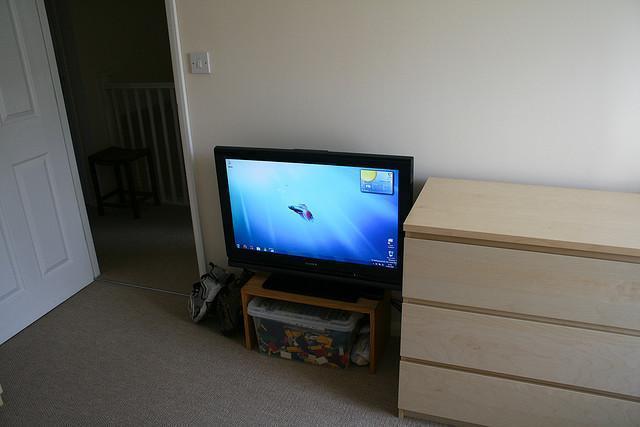How many drawers in the dresser?
Give a very brief answer. 3. 